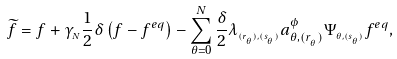Convert formula to latex. <formula><loc_0><loc_0><loc_500><loc_500>\widetilde { f } = f + \gamma _ { _ { N } } \frac { 1 } { 2 } \delta \left ( f - f ^ { e q } \right ) - \sum _ { \theta = 0 } ^ { N } \frac { \delta } { 2 } \lambda _ { _ { ( r _ { _ { \theta } } ) , ( s _ { _ { \theta } } ) } } a _ { \theta , ( r _ { _ { \theta } } ) } ^ { \phi } \Psi _ { _ { \theta , ( s _ { _ { \theta } } ) } } f ^ { e q } ,</formula> 